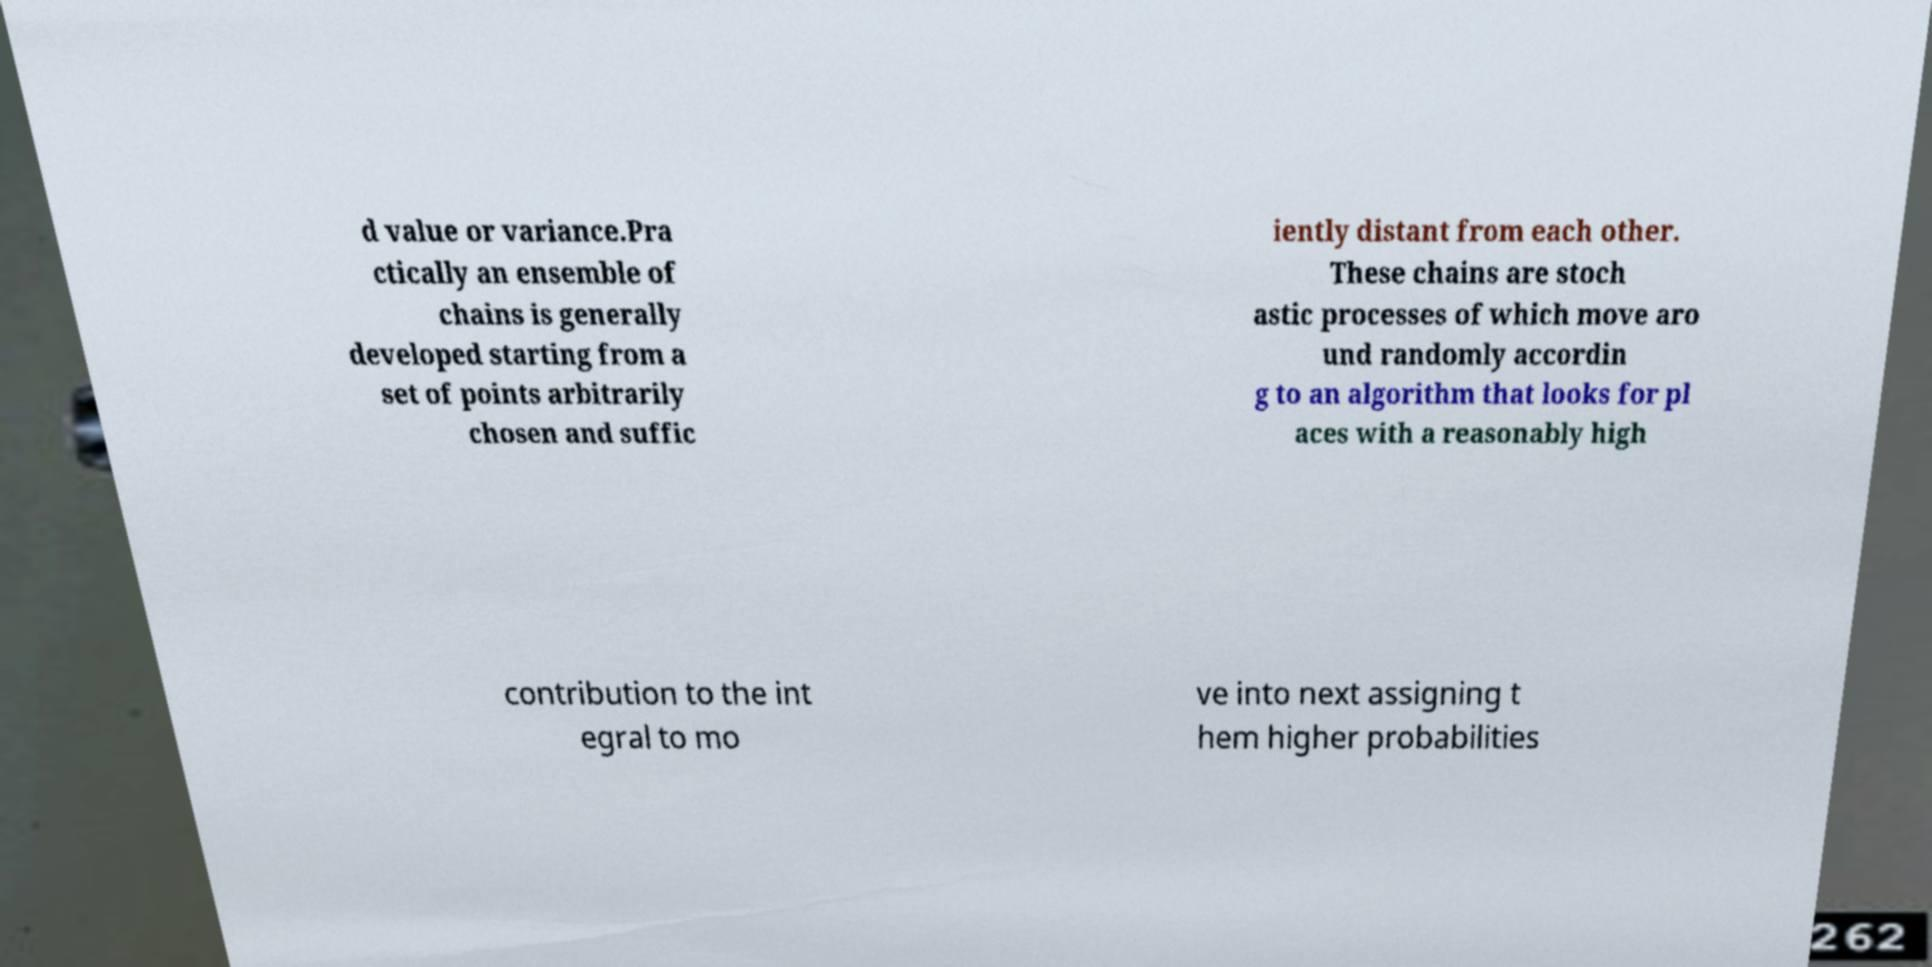I need the written content from this picture converted into text. Can you do that? d value or variance.Pra ctically an ensemble of chains is generally developed starting from a set of points arbitrarily chosen and suffic iently distant from each other. These chains are stoch astic processes of which move aro und randomly accordin g to an algorithm that looks for pl aces with a reasonably high contribution to the int egral to mo ve into next assigning t hem higher probabilities 